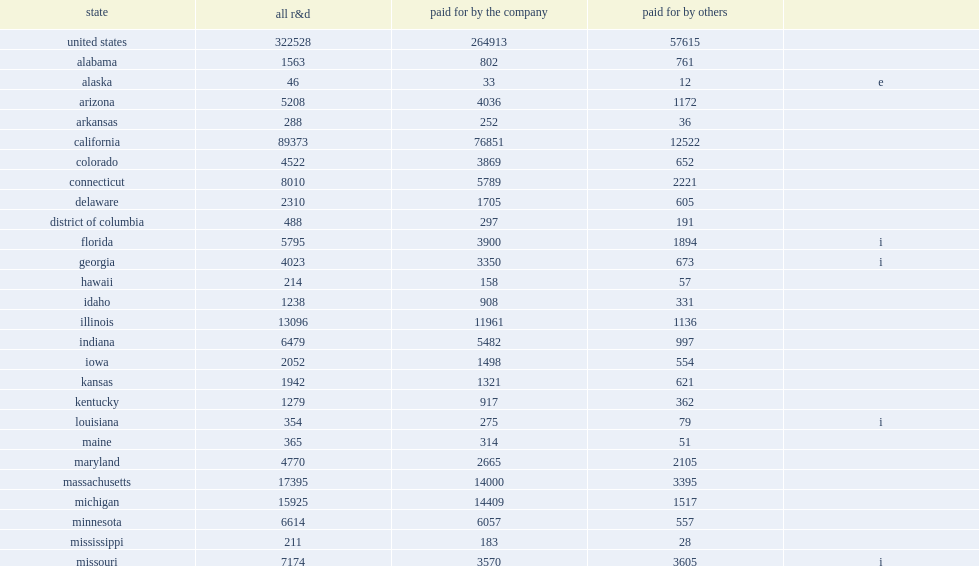During 2013, how many million dollars did companies report of domestic r&d paid for by the company? 264913.0. How many percent did businesses in california alone account of this amount in 2013? 0.277102. 